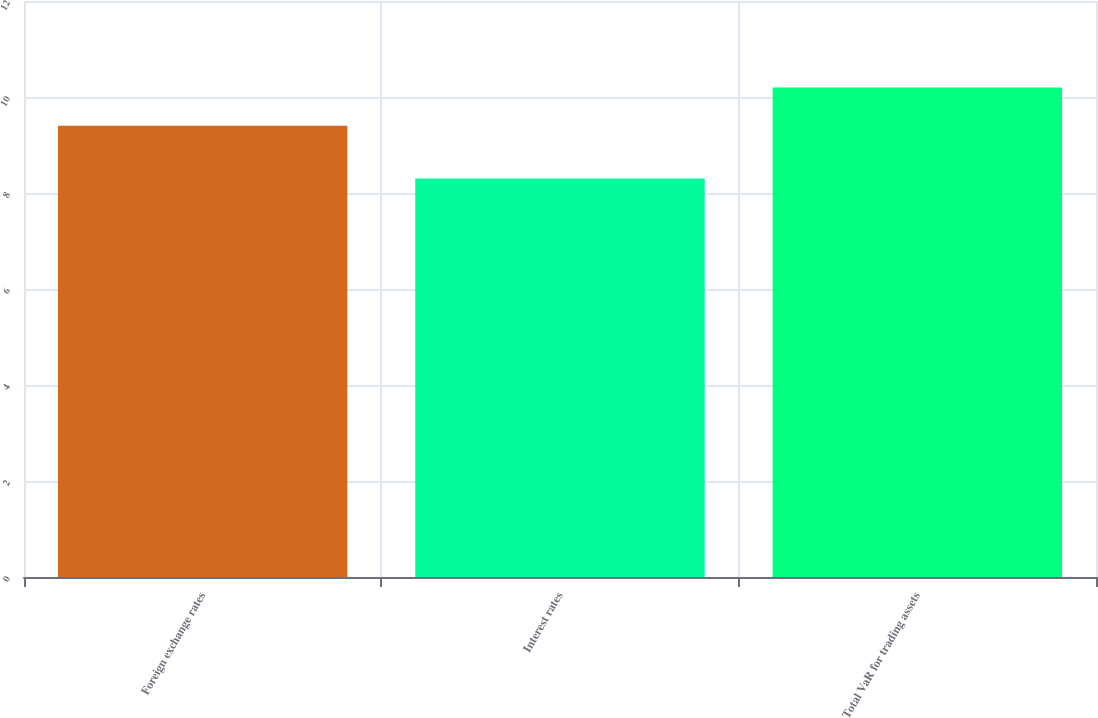Convert chart. <chart><loc_0><loc_0><loc_500><loc_500><bar_chart><fcel>Foreign exchange rates<fcel>Interest rates<fcel>Total VaR for trading assets<nl><fcel>9.4<fcel>8.3<fcel>10.2<nl></chart> 